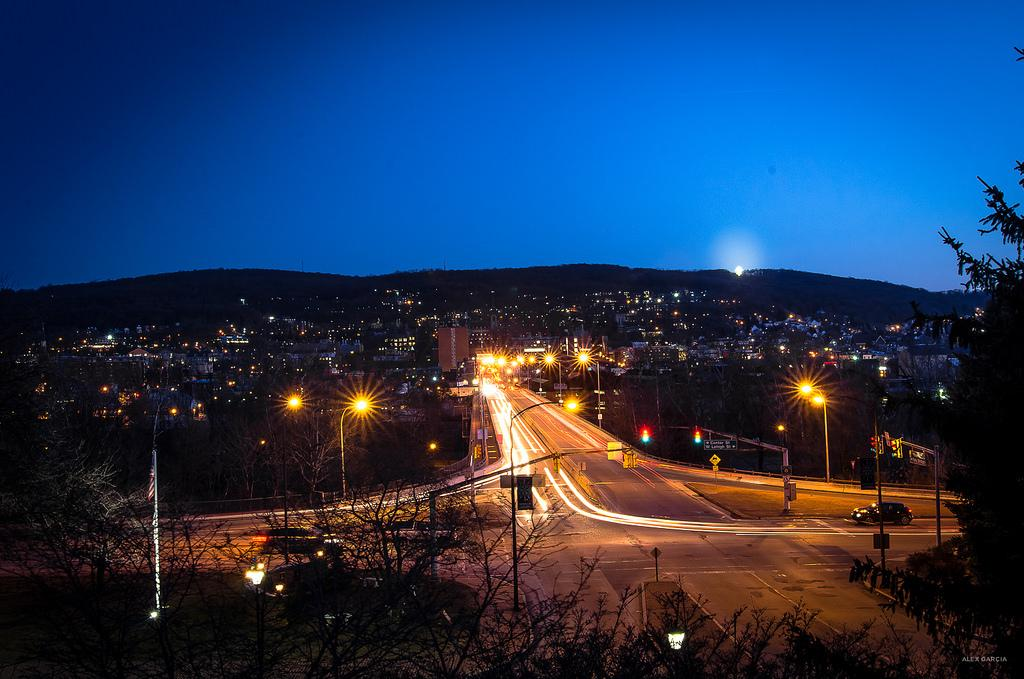What is the main feature of the image? There is a road in the image. What can be seen along the road? The road has lights. What is visible in the background of the image? There are buildings and houses in the background. What color is the sky in the image? The sky is blue at the top of the image. What type of vegetation is at the bottom of the image? There are trees at the bottom of the image. Where are the books located in the image? There are no books present in the image. What type of tub is visible in the image? There is no tub present in the image. 